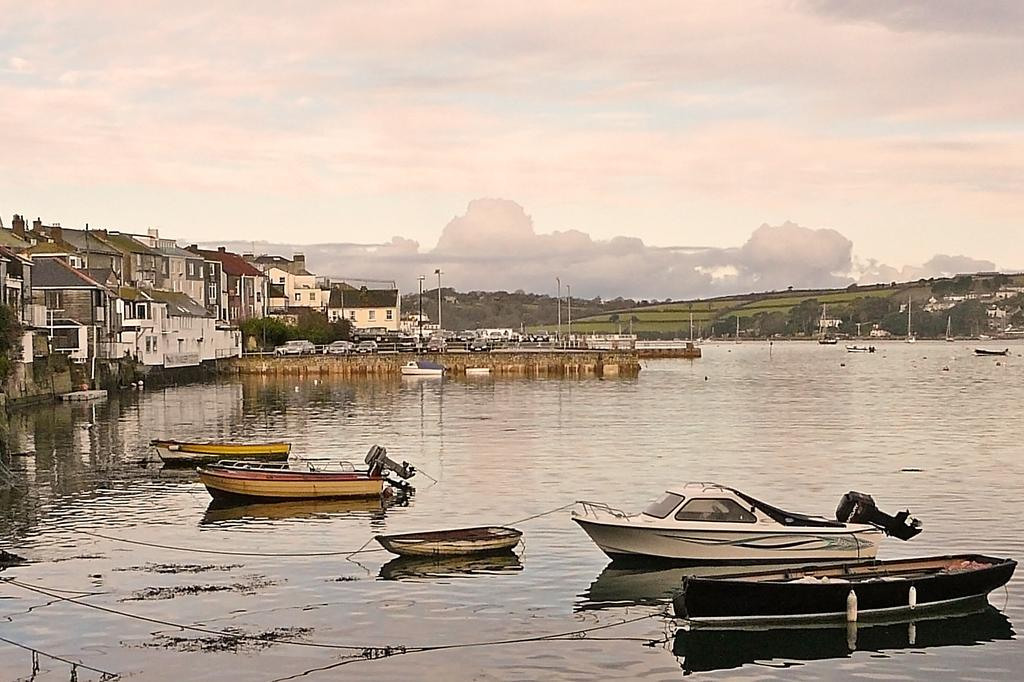What is in the water in the image? There are boats in the water in the image. What structures can be seen in the image? There are buildings visible in the image. What type of transportation is present in the image? There are vehicles present in the image. What type of vegetation is in the vicinity? Trees are in the vicinity in the image. What type of ground cover is visible? Grass is visible in the image. What note is being played on the stage in the image? There is no stage or musical performance present in the image. What is the cause of the traffic jam in the image? There is no traffic jam present in the image. 